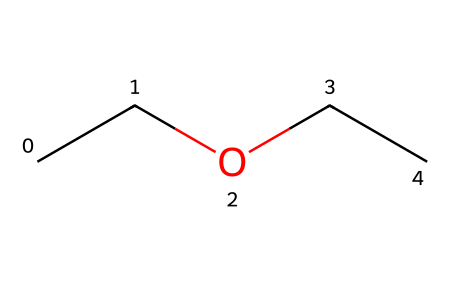What is the molecular formula of diethyl ether? By analyzing the SMILES representation, which indicates two ethyl groups (CC) bonded to an oxygen atom (O), we can count the number of carbon (C), hydrogen (H), and oxygen (O) atoms. There are 4 carbon atoms, 10 hydrogen atoms, and 1 oxygen atom. Therefore, the molecular formula is C4H10O.
Answer: C4H10O How many carbon atoms are in this molecule? Looking at the SMILES notation, there are two "CC" pairs, each representing a carbon atom. Thus, we count 4 carbon atoms in total.
Answer: 4 What type of functional group is present in diethyl ether? The presence of an oxygen atom bonded between two carbon chains indicates the presence of an ether functional group. Thus, diethyl ether contains an ether group (-O-).
Answer: ether Is diethyl ether flammable? Given that diethyl ether is classified as a flammable liquid due to its low flash point and the presence of volatile organic compounds, it indeed is flammable.
Answer: yes What is the significance of the oxygen atom in diethyl ether? The oxygen atom serves as a linker between the two ethyl groups in diethyl ether, which defines its chemical behavior as a solvent in various reactions, including those in anti-venom research.
Answer: linker How does the molecular structure of diethyl ether impact its boiling point? The relatively low boiling point of diethyl ether can be attributed to the weak van der Waals forces between the molecules, due to its non-polar nature and lack of hydrogen bonding, primarily because of the ether functional group.
Answer: low boiling point 